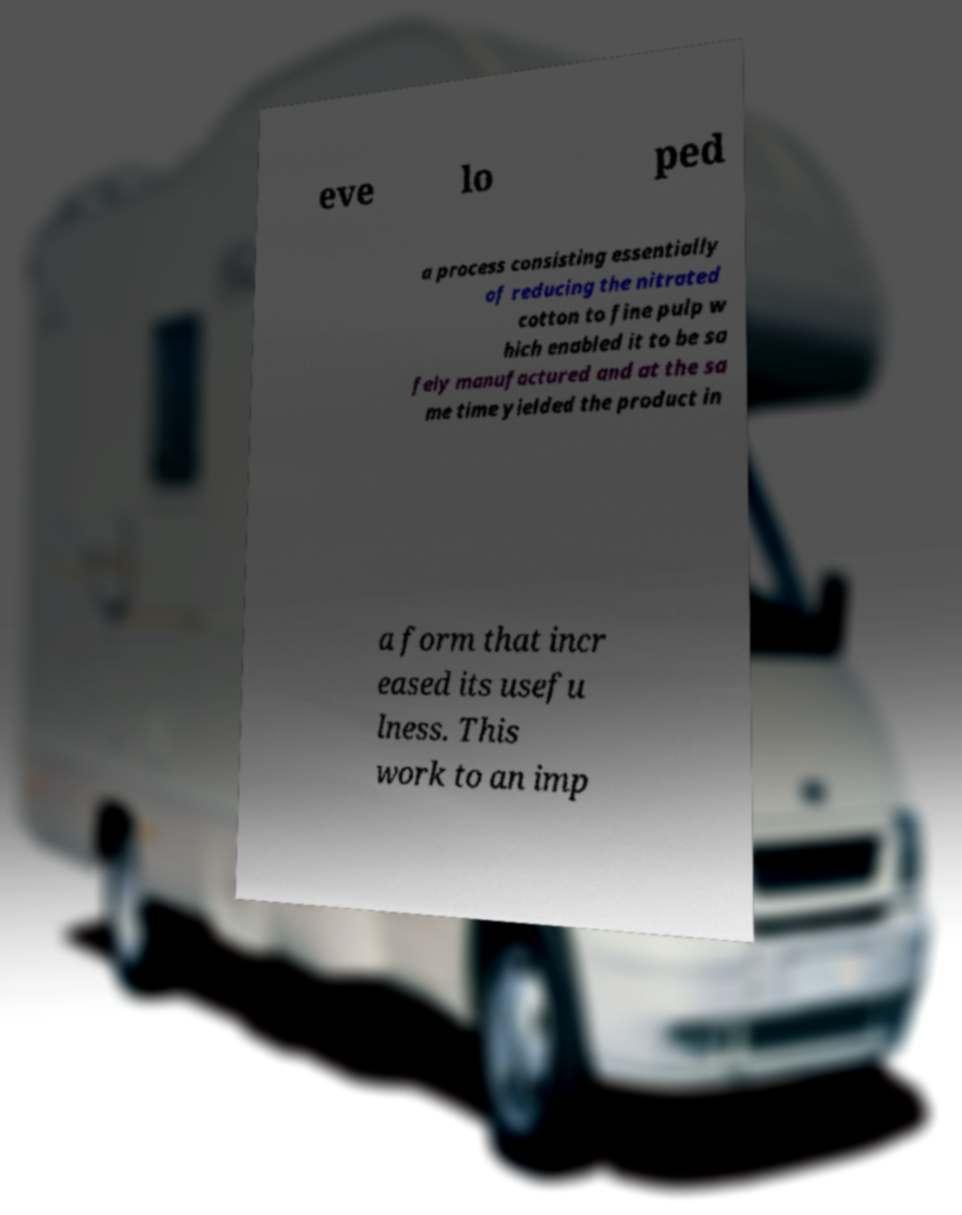Please read and relay the text visible in this image. What does it say? eve lo ped a process consisting essentially of reducing the nitrated cotton to fine pulp w hich enabled it to be sa fely manufactured and at the sa me time yielded the product in a form that incr eased its usefu lness. This work to an imp 